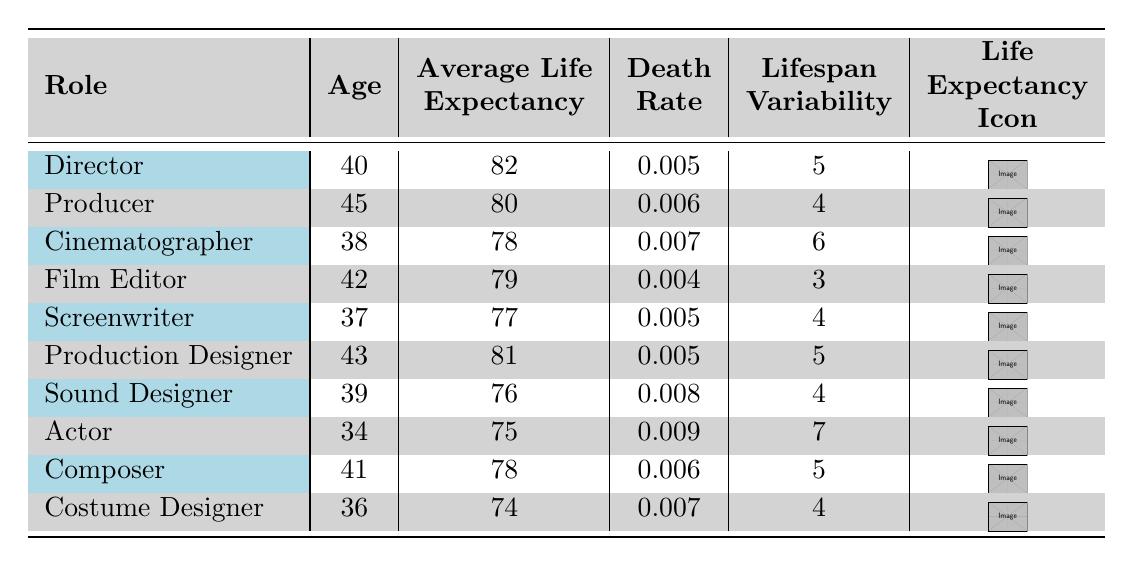What is the average life expectancy of a Director? The table states that the average life expectancy for a Director is listed under the "Average Life Expectancy" column. Looking directly at the data, it shows that the average life expectancy for Directors is 82 years.
Answer: 82 Which role has the highest death rate? To find the role with the highest death rate, we look at the "Death Rate" column for each role. The Actor has a death rate of 0.009, which is higher than the other roles listed.
Answer: Actor What is the difference in average life expectancy between the Cinematographer and the Film Editor? To calculate the difference in life expectancy, we take the average life expectancy for the Cinematographer, which is 78, and subtract the Film Editor's life expectancy of 79. Therefore, 78 - 79 = -1. This indicates that the Film Editor has a higher life expectancy by 1 year.
Answer: 1 Is the average life expectancy of a Producer more than 80 years? We check the Producer's average life expectancy listed in the table. The average life expectancy for a Producer is 80 years, which is not more than 80. Thus, the statement is false.
Answer: No What is the average lifespan variability for all roles combined? To find the average lifespan variability, we sum the lifespan variability values from each role (5 + 4 + 6 + 3 + 4 + 5 + 4 + 7 + 5 + 4 = 57) and divide by the number of roles (10). Hence, 57 / 10 = 5.7.
Answer: 5.7 Which role has the lowest average life expectancy? We scan the "Average Life Expectancy" column to identify the role with the lowest value. The Actor has an average life expectancy of 75 years, which is the lowest compared to all other roles listed.
Answer: Actor If you sum up the ages of all the professionals listed, what would that total be? We first collect the ages (40 + 45 + 38 + 42 + 37 + 43 + 39 + 34 + 41 + 36). Summing these numbers gives us a total of 405 years (40 + 45 = 85, 85 + 38 = 123, 123 + 42 = 165, 165 + 37 = 202, 202 + 43 = 245, 245 + 39 = 284, 284 + 34 = 318, 318 + 41 = 359, 359 + 36 = 405).
Answer: 405 Is the lifespan variability of Screenwriters less than 5? Looking at the lifespan variability for Screenwriters, which is noted in the table as 4, it is indeed less than 5. Therefore, the statement is true.
Answer: Yes Which role has a higher average life expectancy, the Production Designer or the Composer? We compare the average life expectancy of both roles: the Production Designer has an average life expectancy of 81, while the Composer's average is 78. Since 81 is greater than 78, the Production Designer has a higher average life expectancy.
Answer: Production Designer 